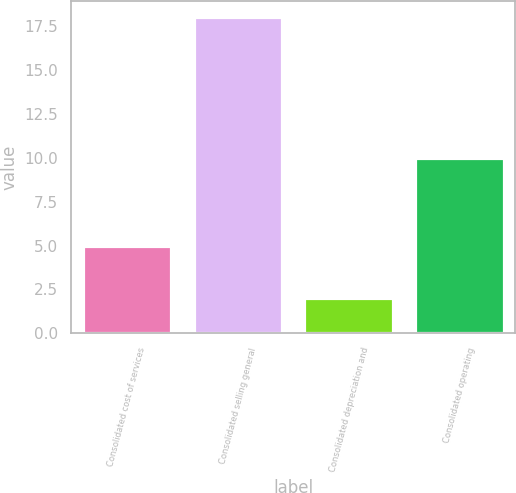<chart> <loc_0><loc_0><loc_500><loc_500><bar_chart><fcel>Consolidated cost of services<fcel>Consolidated selling general<fcel>Consolidated depreciation and<fcel>Consolidated operating<nl><fcel>5<fcel>18<fcel>2<fcel>10<nl></chart> 